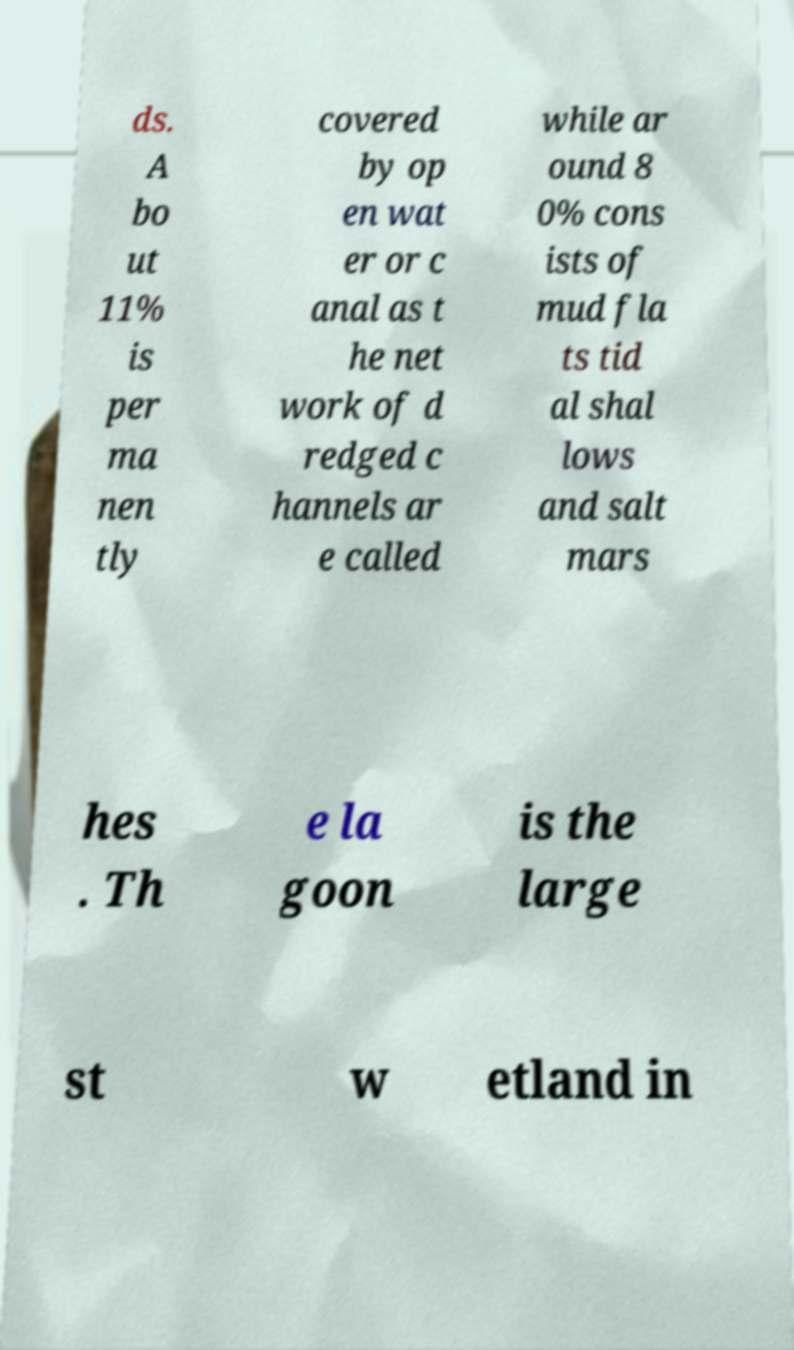Please read and relay the text visible in this image. What does it say? ds. A bo ut 11% is per ma nen tly covered by op en wat er or c anal as t he net work of d redged c hannels ar e called while ar ound 8 0% cons ists of mud fla ts tid al shal lows and salt mars hes . Th e la goon is the large st w etland in 